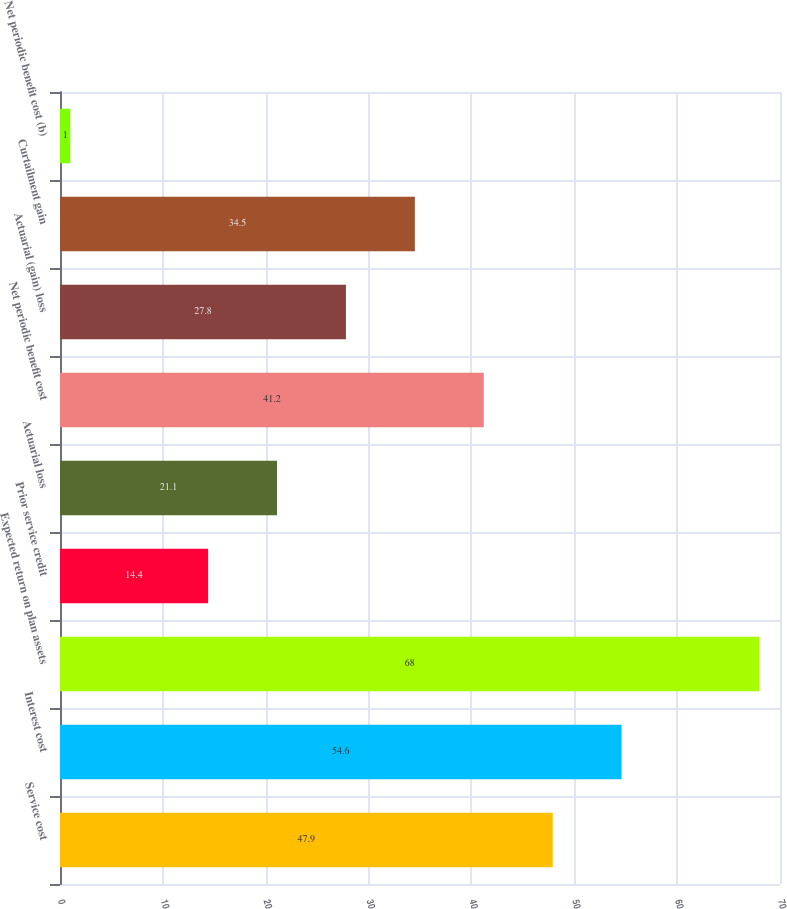Convert chart to OTSL. <chart><loc_0><loc_0><loc_500><loc_500><bar_chart><fcel>Service cost<fcel>Interest cost<fcel>Expected return on plan assets<fcel>Prior service credit<fcel>Actuarial loss<fcel>Net periodic benefit cost<fcel>Actuarial (gain) loss<fcel>Curtailment gain<fcel>Net periodic benefit cost (b)<nl><fcel>47.9<fcel>54.6<fcel>68<fcel>14.4<fcel>21.1<fcel>41.2<fcel>27.8<fcel>34.5<fcel>1<nl></chart> 